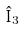Convert formula to latex. <formula><loc_0><loc_0><loc_500><loc_500>\hat { I } _ { 3 }</formula> 